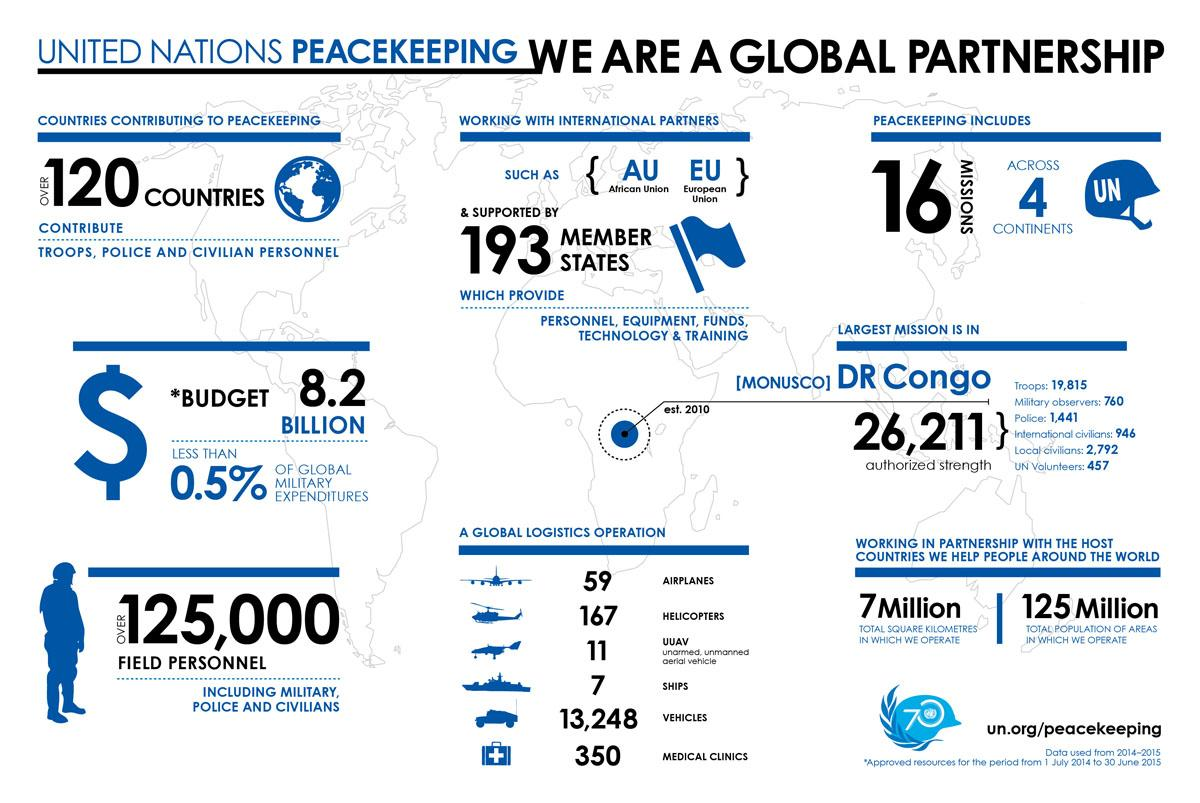Give some essential details in this illustration. As of 2021, a total of 16 United Nations peacekeeping missions have been deployed across different continents. The total budget for the United Nations peacekeeping missions is 8.2 BILLION dollars. Over 120 countries contribute to the United Nations peacekeeping missions, demonstrating the global commitment to maintaining international peace and security. As of the latest UN mission in Monusco, a total of 26,211 forces have been deployed. The total population of areas where UN peacekeepers operate is approximately 125 million. 